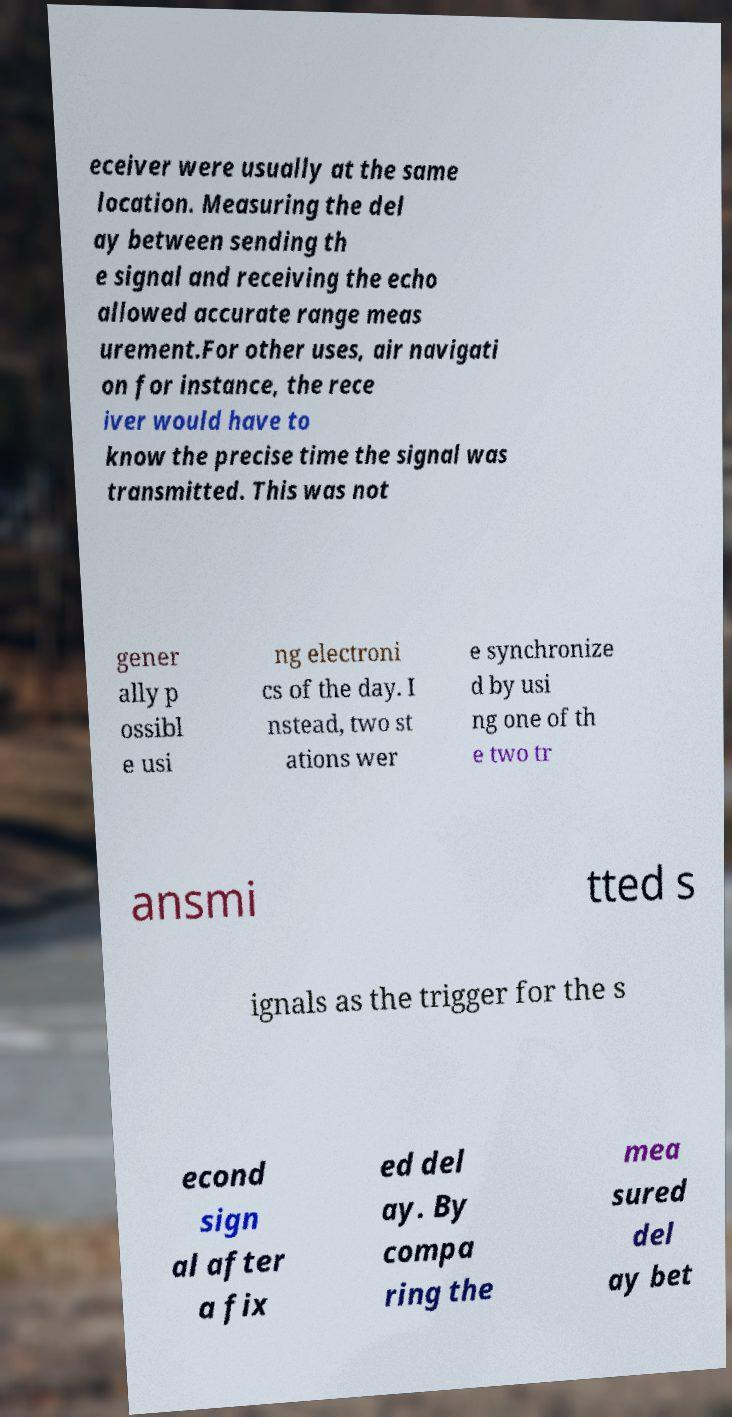For documentation purposes, I need the text within this image transcribed. Could you provide that? eceiver were usually at the same location. Measuring the del ay between sending th e signal and receiving the echo allowed accurate range meas urement.For other uses, air navigati on for instance, the rece iver would have to know the precise time the signal was transmitted. This was not gener ally p ossibl e usi ng electroni cs of the day. I nstead, two st ations wer e synchronize d by usi ng one of th e two tr ansmi tted s ignals as the trigger for the s econd sign al after a fix ed del ay. By compa ring the mea sured del ay bet 